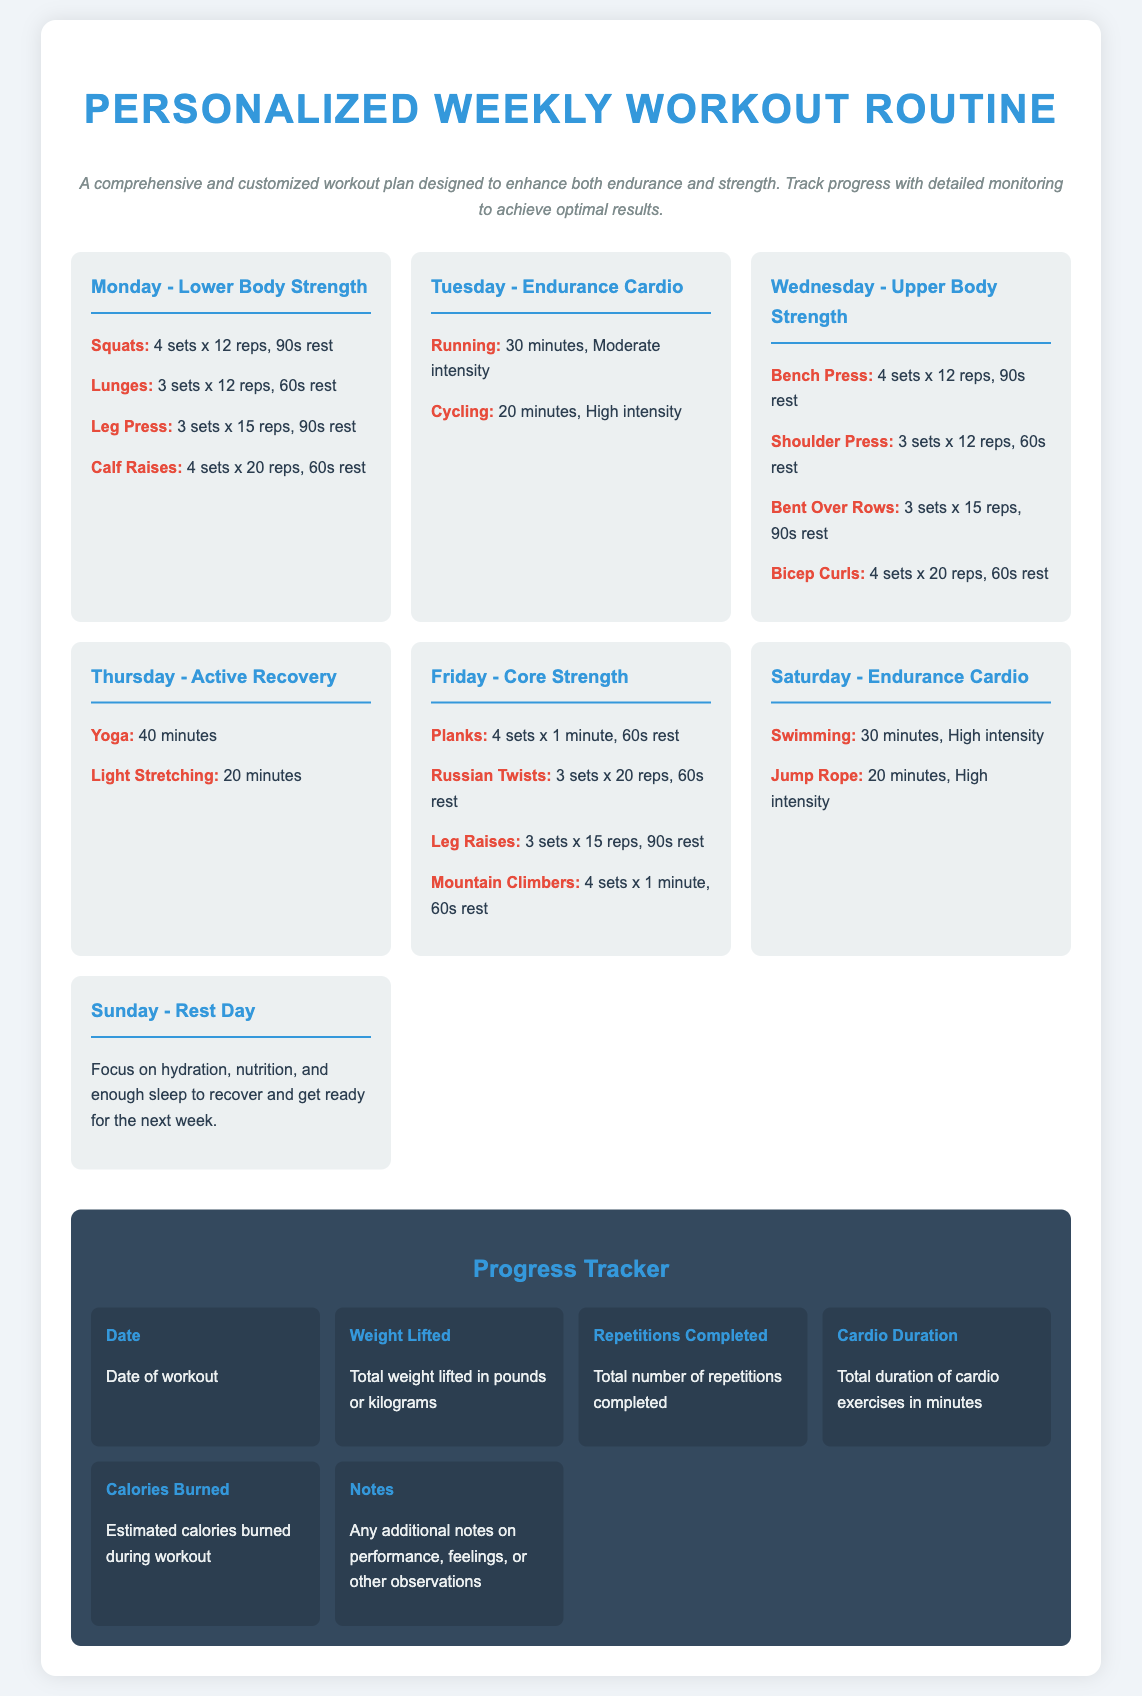What exercises are included on Monday? The exercises listed for Monday are Squats, Lunges, Leg Press, and Calf Raises.
Answer: Squats, Lunges, Leg Press, Calf Raises How long is the cardio session on Tuesday? The cardio session on Tuesday consists of a 30-minute running workout and a 20-minute cycling workout.
Answer: 30 minutes What type of workout is done on Wednesday? The workout on Wednesday focuses on Upper Body Strength with various exercises.
Answer: Upper Body Strength How many sets of Planks are included on Friday? Friday has a total of 4 sets of Planks scheduled as part of the Core Strength workout.
Answer: 4 sets What is the purpose of Sunday in the workout routine? Sunday is designated as a Rest Day, focusing on recovery through hydration and nutrition.
Answer: Rest Day What is the total duration of cardio exercises measured in the progress tracker? The progress tracker includes a metric for Total duration of cardio exercises measured in minutes.
Answer: Total duration of cardio exercises in minutes How many exercises are listed for Thursday? Thursday includes 2 exercises focused on Active Recovery.
Answer: 2 exercises What intensity level is recommended for the Running session on Tuesday? The Running session on Tuesday is suggested at a Moderate intensity.
Answer: Moderate intensity 